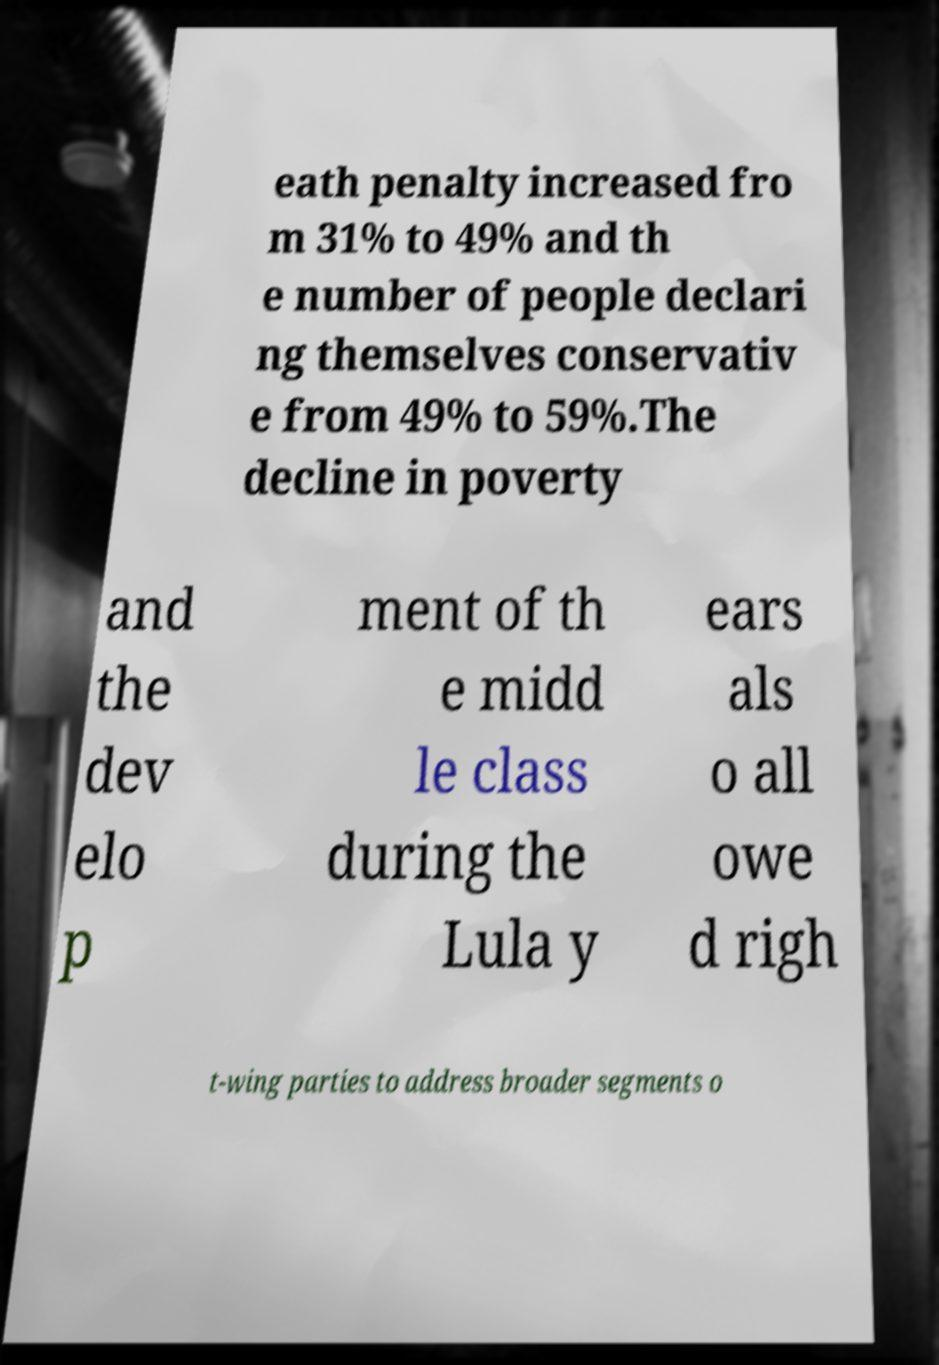Could you assist in decoding the text presented in this image and type it out clearly? eath penalty increased fro m 31% to 49% and th e number of people declari ng themselves conservativ e from 49% to 59%.The decline in poverty and the dev elo p ment of th e midd le class during the Lula y ears als o all owe d righ t-wing parties to address broader segments o 